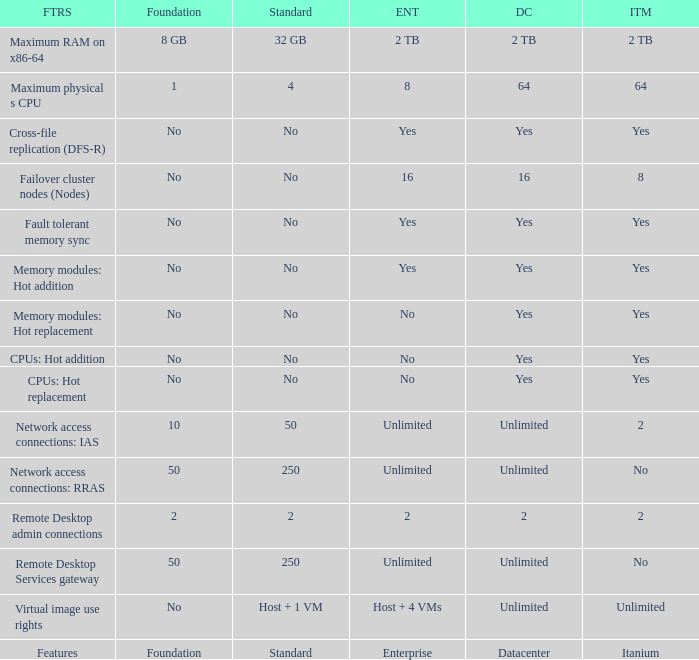Which Features have Yes listed under Datacenter? Cross-file replication (DFS-R), Fault tolerant memory sync, Memory modules: Hot addition, Memory modules: Hot replacement, CPUs: Hot addition, CPUs: Hot replacement. Could you parse the entire table? {'header': ['FTRS', 'Foundation', 'Standard', 'ENT', 'DC', 'ITM'], 'rows': [['Maximum RAM on x86-64', '8 GB', '32 GB', '2 TB', '2 TB', '2 TB'], ['Maximum physical s CPU', '1', '4', '8', '64', '64'], ['Cross-file replication (DFS-R)', 'No', 'No', 'Yes', 'Yes', 'Yes'], ['Failover cluster nodes (Nodes)', 'No', 'No', '16', '16', '8'], ['Fault tolerant memory sync', 'No', 'No', 'Yes', 'Yes', 'Yes'], ['Memory modules: Hot addition', 'No', 'No', 'Yes', 'Yes', 'Yes'], ['Memory modules: Hot replacement', 'No', 'No', 'No', 'Yes', 'Yes'], ['CPUs: Hot addition', 'No', 'No', 'No', 'Yes', 'Yes'], ['CPUs: Hot replacement', 'No', 'No', 'No', 'Yes', 'Yes'], ['Network access connections: IAS', '10', '50', 'Unlimited', 'Unlimited', '2'], ['Network access connections: RRAS', '50', '250', 'Unlimited', 'Unlimited', 'No'], ['Remote Desktop admin connections', '2', '2', '2', '2', '2'], ['Remote Desktop Services gateway', '50', '250', 'Unlimited', 'Unlimited', 'No'], ['Virtual image use rights', 'No', 'Host + 1 VM', 'Host + 4 VMs', 'Unlimited', 'Unlimited'], ['Features', 'Foundation', 'Standard', 'Enterprise', 'Datacenter', 'Itanium']]} 